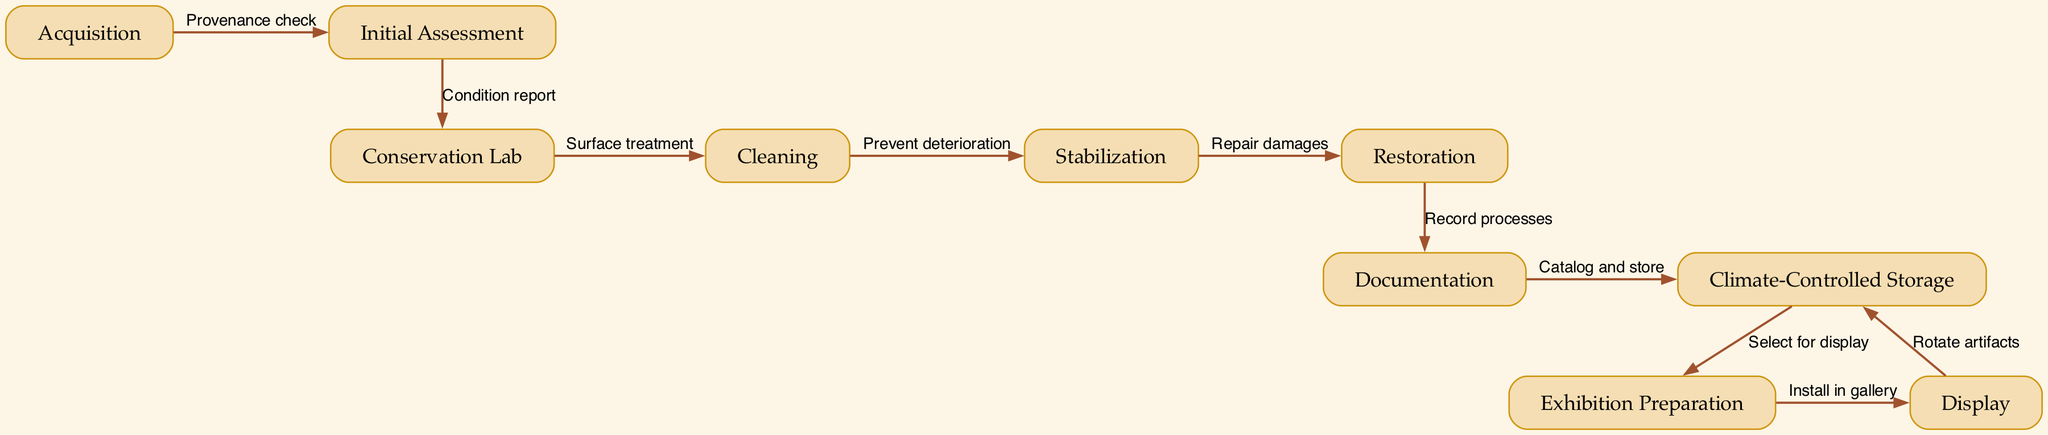What is the first step after Acquisition? The first step after Acquisition is indicated as Initial Assessment, which directly follows the "Provenance check" associated with Acquisition.
Answer: Initial Assessment How many nodes are there in the diagram? The diagram contains a total of ten nodes that represent different stages in the artifact flow, as listed in the data.
Answer: 10 What is the final step before Display? The final step before Display is Exhibition Preparation, as it is the penultimate node in the directed graph leading to Display.
Answer: Exhibition Preparation What process follows Cleaning? The process that directly follows Cleaning is Stabilization, as shown in the flow from Cleaning to Stabilization with the purpose of preventing deterioration.
Answer: Stabilization Which two steps connect Documentation and Climate-Controlled Storage? Documentation connects to Climate-Controlled Storage through the process of cataloging and storing the artifacts, forming a direct edge in the diagram.
Answer: Catalog and store What are the two steps that lead into the Conservation Lab? There is one direct step into Conservation Lab from Initial Assessment, which is the result of the condition report. Therefore, there is only one flow leading into the Conservation Lab.
Answer: Initial Assessment How many edges are there in the diagram? The diagram features a total of nine edges that represent the relationships and processes among the ten nodes.
Answer: 9 What is the purpose of Restoration in the artifact flow? The purpose of Restoration is to repair damages caused to the artifact, as indicated by the direct flow from Stabilization to Restoration.
Answer: Repair damages From which step do artifacts rotate back into Climate-Controlled Storage? Artifacts rotate back into Climate-Controlled Storage from the Display step, as indicated by the flow returning after the exhibition.
Answer: Display 